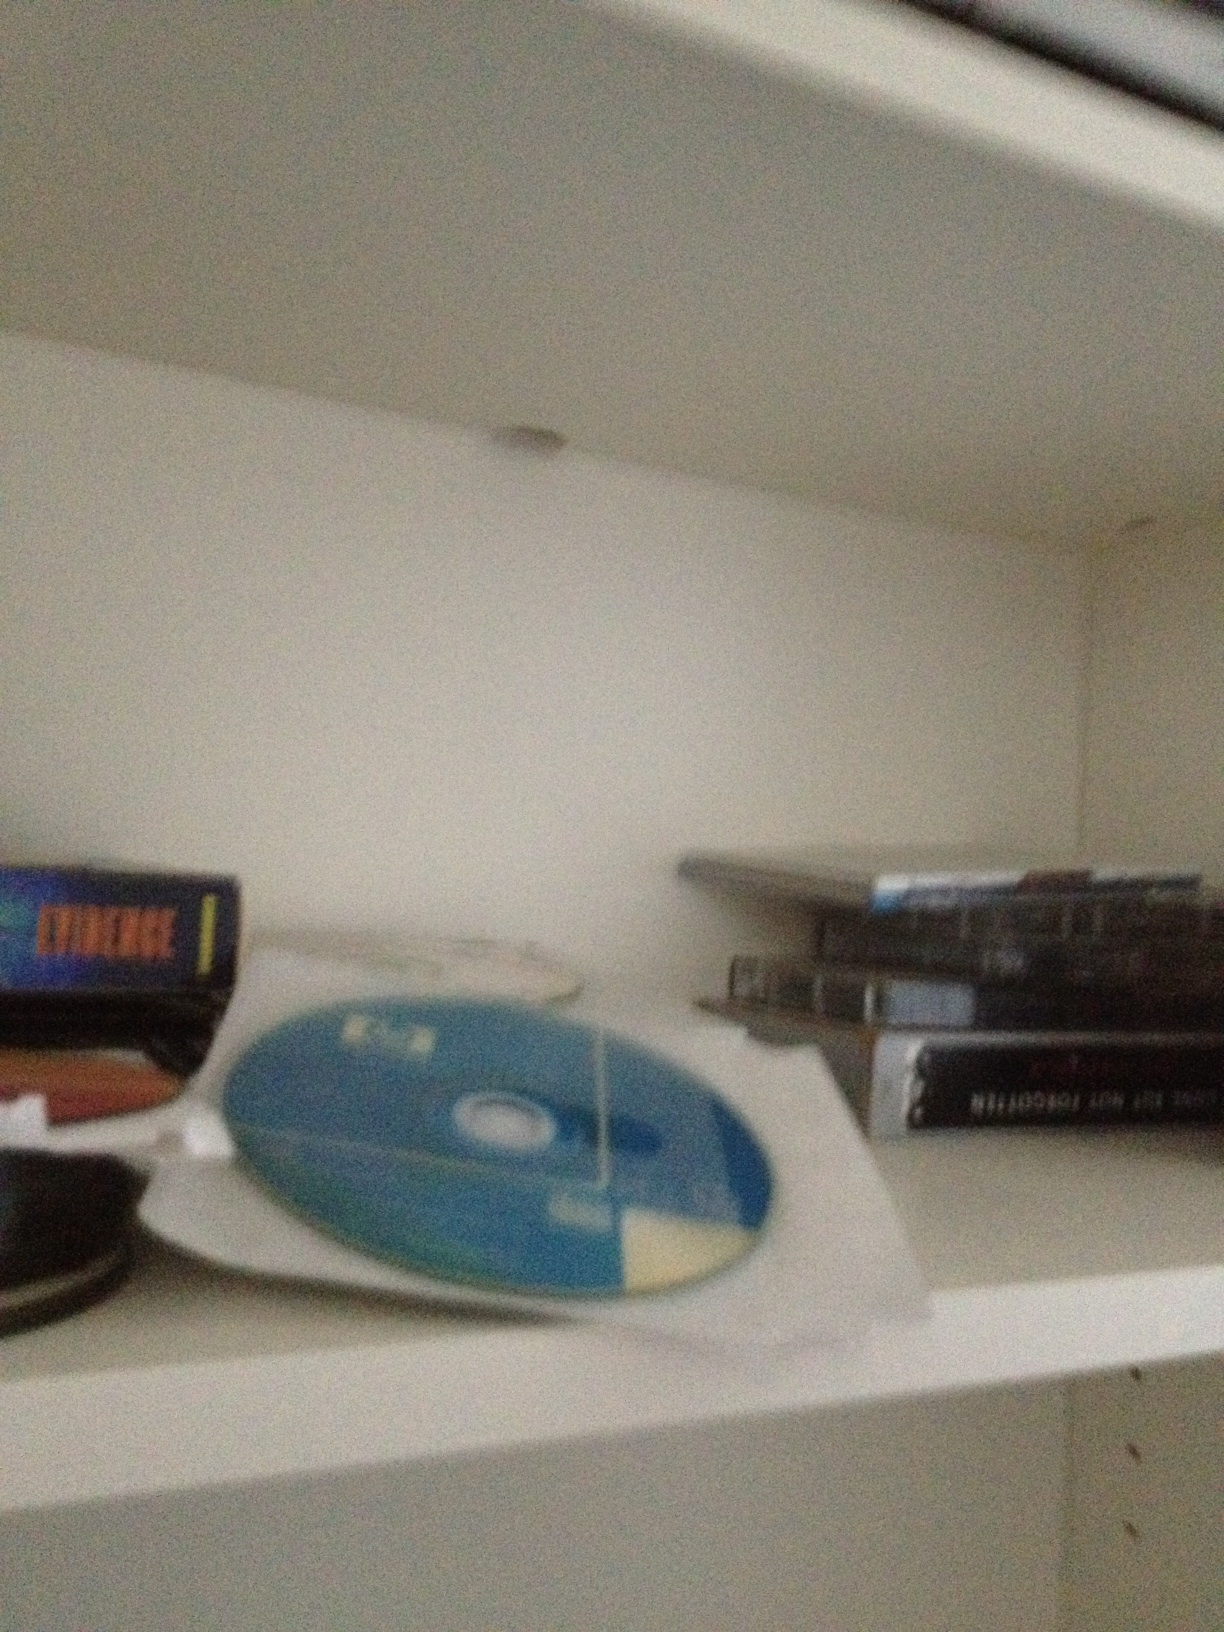Why might someone choose to display their CD and DVD collection prominently? Someone might display their CD and DVD collection prominently to showcase their diverse tastes and interests to visitors. It can serve as a conversation starter, reflecting various periods in their life or different genres they enjoy. Displaying the collection also makes it easily accessible for use, allowing them to quickly find and play their favorite media. Additionally, for many, such collections represent a significant personal investment, both financially and emotionally, and they take pride in sharing that with others. 